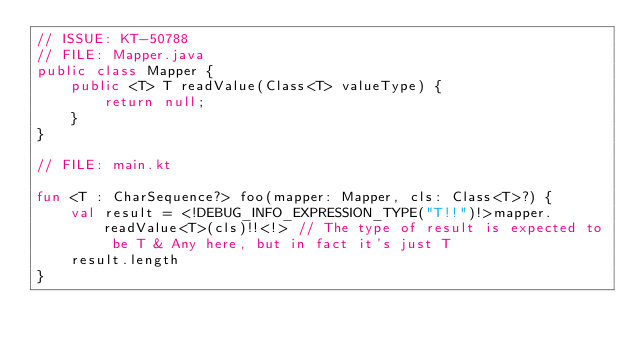<code> <loc_0><loc_0><loc_500><loc_500><_Kotlin_>// ISSUE: KT-50788
// FILE: Mapper.java
public class Mapper {
    public <T> T readValue(Class<T> valueType) {
        return null;
    }
}

// FILE: main.kt

fun <T : CharSequence?> foo(mapper: Mapper, cls: Class<T>?) {
    val result = <!DEBUG_INFO_EXPRESSION_TYPE("T!!")!>mapper.readValue<T>(cls)!!<!> // The type of result is expected to be T & Any here, but in fact it's just T
    result.length
}
</code> 